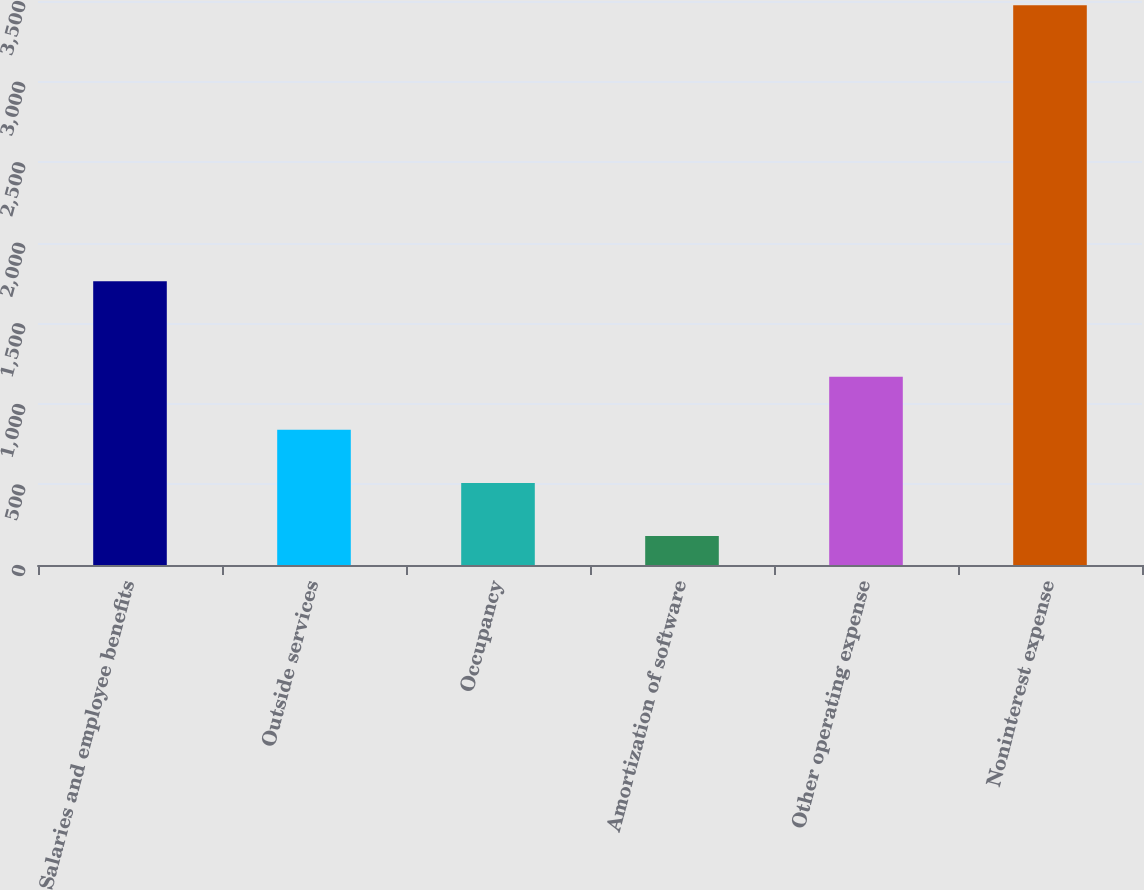Convert chart. <chart><loc_0><loc_0><loc_500><loc_500><bar_chart><fcel>Salaries and employee benefits<fcel>Outside services<fcel>Occupancy<fcel>Amortization of software<fcel>Other operating expense<fcel>Noninterest expense<nl><fcel>1761<fcel>838.8<fcel>509.4<fcel>180<fcel>1168.2<fcel>3474<nl></chart> 